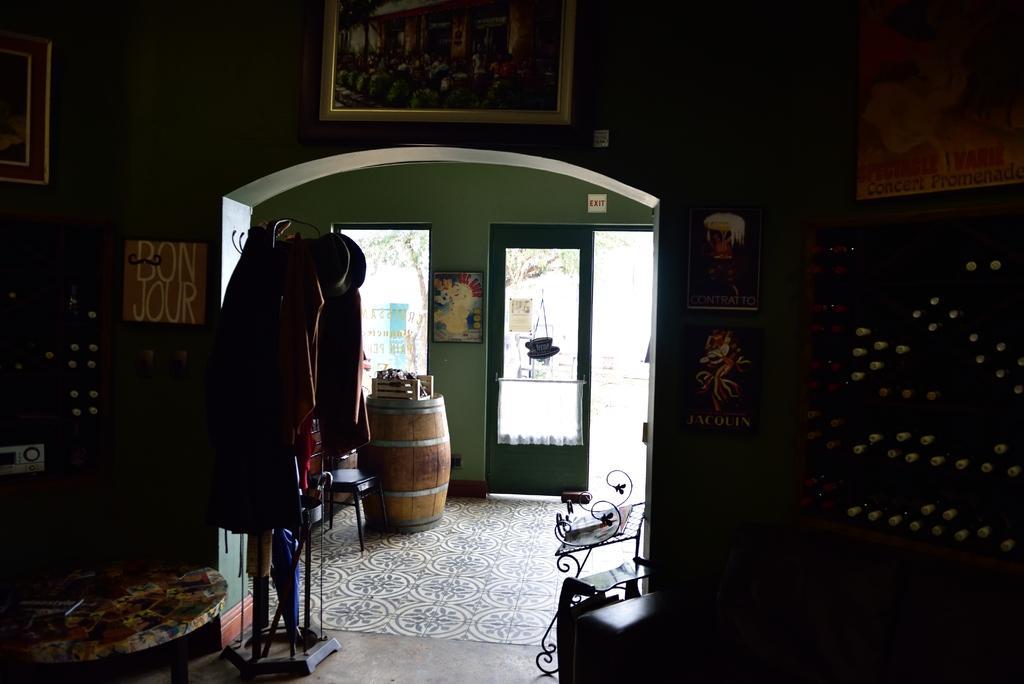Please provide a concise description of this image. This part of the image is dark where we can see photo frames on the wall, we can see the table on which we can see some objects are placed, we can see a stand on which sweaters and hats are hanged, we can see the wooden barrels, stool and glass doors through which we can see the trees and here we can see the exit board. 